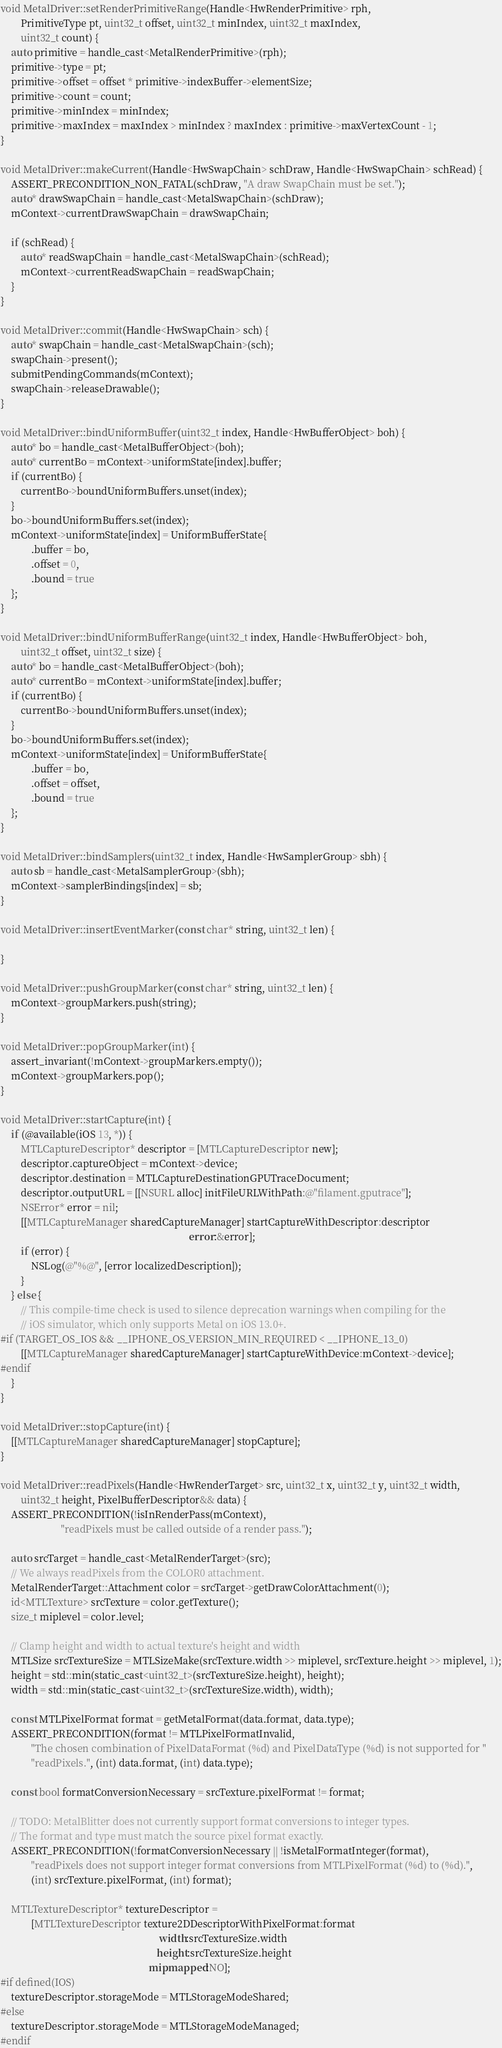<code> <loc_0><loc_0><loc_500><loc_500><_ObjectiveC_>void MetalDriver::setRenderPrimitiveRange(Handle<HwRenderPrimitive> rph,
        PrimitiveType pt, uint32_t offset, uint32_t minIndex, uint32_t maxIndex,
        uint32_t count) {
    auto primitive = handle_cast<MetalRenderPrimitive>(rph);
    primitive->type = pt;
    primitive->offset = offset * primitive->indexBuffer->elementSize;
    primitive->count = count;
    primitive->minIndex = minIndex;
    primitive->maxIndex = maxIndex > minIndex ? maxIndex : primitive->maxVertexCount - 1;
}

void MetalDriver::makeCurrent(Handle<HwSwapChain> schDraw, Handle<HwSwapChain> schRead) {
    ASSERT_PRECONDITION_NON_FATAL(schDraw, "A draw SwapChain must be set.");
    auto* drawSwapChain = handle_cast<MetalSwapChain>(schDraw);
    mContext->currentDrawSwapChain = drawSwapChain;

    if (schRead) {
        auto* readSwapChain = handle_cast<MetalSwapChain>(schRead);
        mContext->currentReadSwapChain = readSwapChain;
    }
}

void MetalDriver::commit(Handle<HwSwapChain> sch) {
    auto* swapChain = handle_cast<MetalSwapChain>(sch);
    swapChain->present();
    submitPendingCommands(mContext);
    swapChain->releaseDrawable();
}

void MetalDriver::bindUniformBuffer(uint32_t index, Handle<HwBufferObject> boh) {
    auto* bo = handle_cast<MetalBufferObject>(boh);
    auto* currentBo = mContext->uniformState[index].buffer;
    if (currentBo) {
        currentBo->boundUniformBuffers.unset(index);
    }
    bo->boundUniformBuffers.set(index);
    mContext->uniformState[index] = UniformBufferState{
            .buffer = bo,
            .offset = 0,
            .bound = true
    };
}

void MetalDriver::bindUniformBufferRange(uint32_t index, Handle<HwBufferObject> boh,
        uint32_t offset, uint32_t size) {
    auto* bo = handle_cast<MetalBufferObject>(boh);
    auto* currentBo = mContext->uniformState[index].buffer;
    if (currentBo) {
        currentBo->boundUniformBuffers.unset(index);
    }
    bo->boundUniformBuffers.set(index);
    mContext->uniformState[index] = UniformBufferState{
            .buffer = bo,
            .offset = offset,
            .bound = true
    };
}

void MetalDriver::bindSamplers(uint32_t index, Handle<HwSamplerGroup> sbh) {
    auto sb = handle_cast<MetalSamplerGroup>(sbh);
    mContext->samplerBindings[index] = sb;
}

void MetalDriver::insertEventMarker(const char* string, uint32_t len) {

}

void MetalDriver::pushGroupMarker(const char* string, uint32_t len) {
    mContext->groupMarkers.push(string);
}

void MetalDriver::popGroupMarker(int) {
    assert_invariant(!mContext->groupMarkers.empty());
    mContext->groupMarkers.pop();
}

void MetalDriver::startCapture(int) {
    if (@available(iOS 13, *)) {
        MTLCaptureDescriptor* descriptor = [MTLCaptureDescriptor new];
        descriptor.captureObject = mContext->device;
        descriptor.destination = MTLCaptureDestinationGPUTraceDocument;
        descriptor.outputURL = [[NSURL alloc] initFileURLWithPath:@"filament.gputrace"];
        NSError* error = nil;
        [[MTLCaptureManager sharedCaptureManager] startCaptureWithDescriptor:descriptor
                                                                           error:&error];
        if (error) {
            NSLog(@"%@", [error localizedDescription]);
        }
    } else {
        // This compile-time check is used to silence deprecation warnings when compiling for the
        // iOS simulator, which only supports Metal on iOS 13.0+.
#if (TARGET_OS_IOS && __IPHONE_OS_VERSION_MIN_REQUIRED < __IPHONE_13_0)
        [[MTLCaptureManager sharedCaptureManager] startCaptureWithDevice:mContext->device];
#endif
    }
}

void MetalDriver::stopCapture(int) {
    [[MTLCaptureManager sharedCaptureManager] stopCapture];
}

void MetalDriver::readPixels(Handle<HwRenderTarget> src, uint32_t x, uint32_t y, uint32_t width,
        uint32_t height, PixelBufferDescriptor&& data) {
    ASSERT_PRECONDITION(!isInRenderPass(mContext),
                        "readPixels must be called outside of a render pass.");

    auto srcTarget = handle_cast<MetalRenderTarget>(src);
    // We always readPixels from the COLOR0 attachment.
    MetalRenderTarget::Attachment color = srcTarget->getDrawColorAttachment(0);
    id<MTLTexture> srcTexture = color.getTexture();
    size_t miplevel = color.level;

    // Clamp height and width to actual texture's height and width
    MTLSize srcTextureSize = MTLSizeMake(srcTexture.width >> miplevel, srcTexture.height >> miplevel, 1);
    height = std::min(static_cast<uint32_t>(srcTextureSize.height), height);
    width = std::min(static_cast<uint32_t>(srcTextureSize.width), width);

    const MTLPixelFormat format = getMetalFormat(data.format, data.type);
    ASSERT_PRECONDITION(format != MTLPixelFormatInvalid,
            "The chosen combination of PixelDataFormat (%d) and PixelDataType (%d) is not supported for "
            "readPixels.", (int) data.format, (int) data.type);

    const bool formatConversionNecessary = srcTexture.pixelFormat != format;

    // TODO: MetalBlitter does not currently support format conversions to integer types.
    // The format and type must match the source pixel format exactly.
    ASSERT_PRECONDITION(!formatConversionNecessary || !isMetalFormatInteger(format),
            "readPixels does not support integer format conversions from MTLPixelFormat (%d) to (%d).",
            (int) srcTexture.pixelFormat, (int) format);

    MTLTextureDescriptor* textureDescriptor =
            [MTLTextureDescriptor texture2DDescriptorWithPixelFormat:format
                                                               width:srcTextureSize.width
                                                              height:srcTextureSize.height
                                                           mipmapped:NO];
#if defined(IOS)
    textureDescriptor.storageMode = MTLStorageModeShared;
#else
    textureDescriptor.storageMode = MTLStorageModeManaged;
#endif</code> 